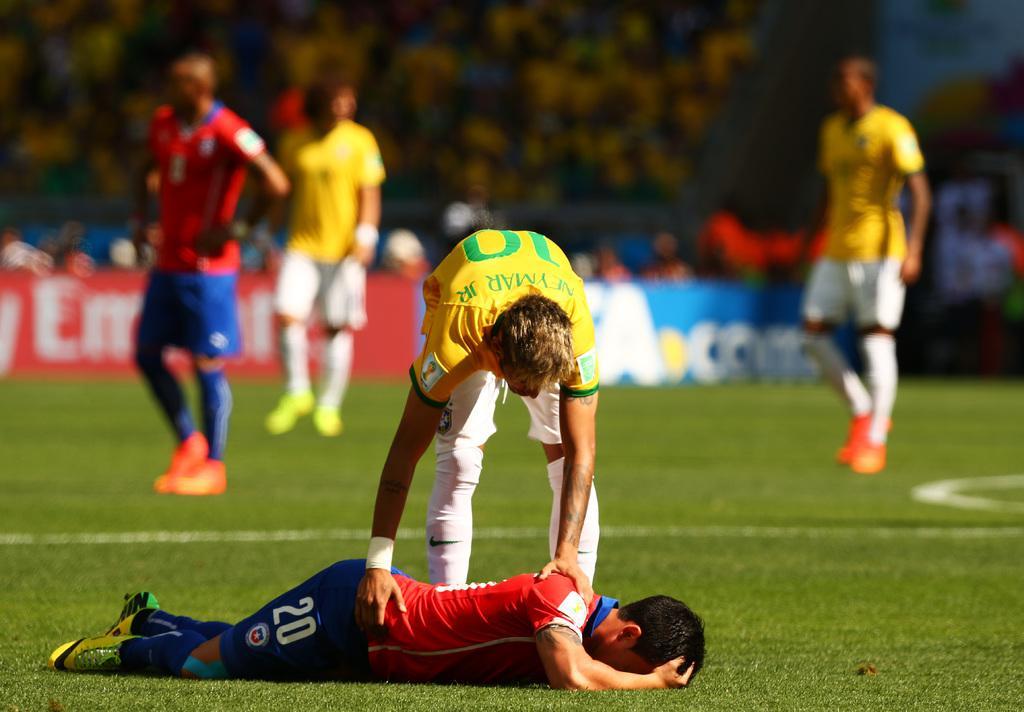In one or two sentences, can you explain what this image depicts? This picture is clicked outside. In the foreground we can see a person wearing red color t-shirt and lying on the ground and a person wearing yellow color t-shirt, standing on the ground and bending forward, we can see the green grass and the text on the banners and we can see the group of persons seems to be walking on the ground. The background of the image is blurry and we can see some other objects in the background. 